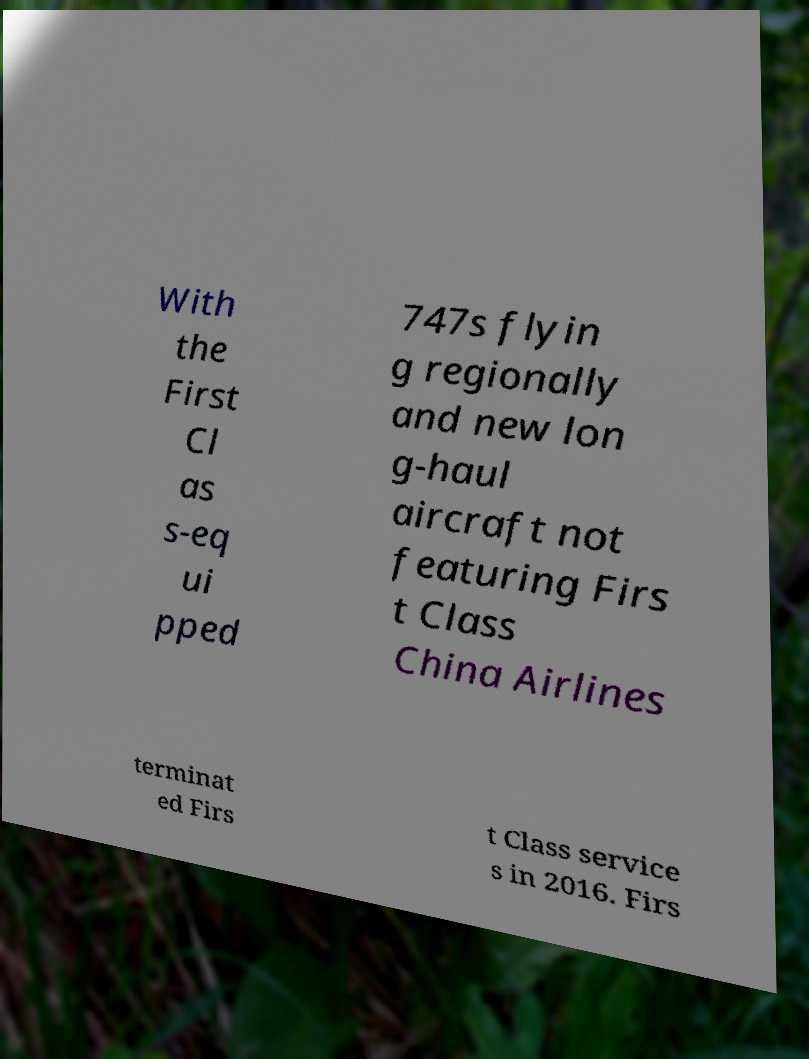Can you accurately transcribe the text from the provided image for me? With the First Cl as s-eq ui pped 747s flyin g regionally and new lon g-haul aircraft not featuring Firs t Class China Airlines terminat ed Firs t Class service s in 2016. Firs 